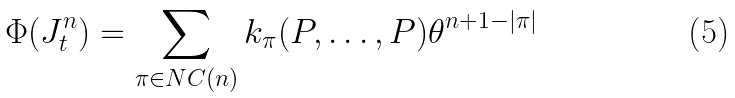Convert formula to latex. <formula><loc_0><loc_0><loc_500><loc_500>\Phi ( J _ { t } ^ { n } ) = \sum _ { \pi \in N C ( n ) } k _ { \pi } ( P , \dots , P ) \theta ^ { n + 1 - | \pi | }</formula> 